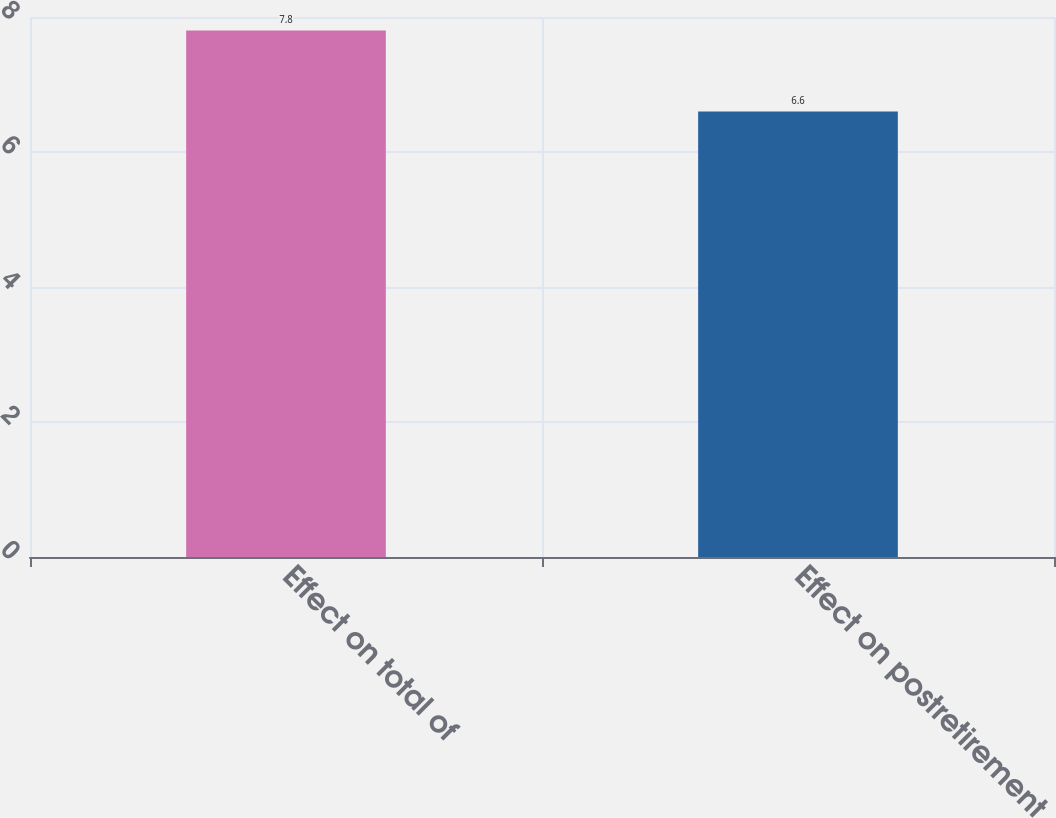Convert chart. <chart><loc_0><loc_0><loc_500><loc_500><bar_chart><fcel>Effect on total of<fcel>Effect on postretirement<nl><fcel>7.8<fcel>6.6<nl></chart> 